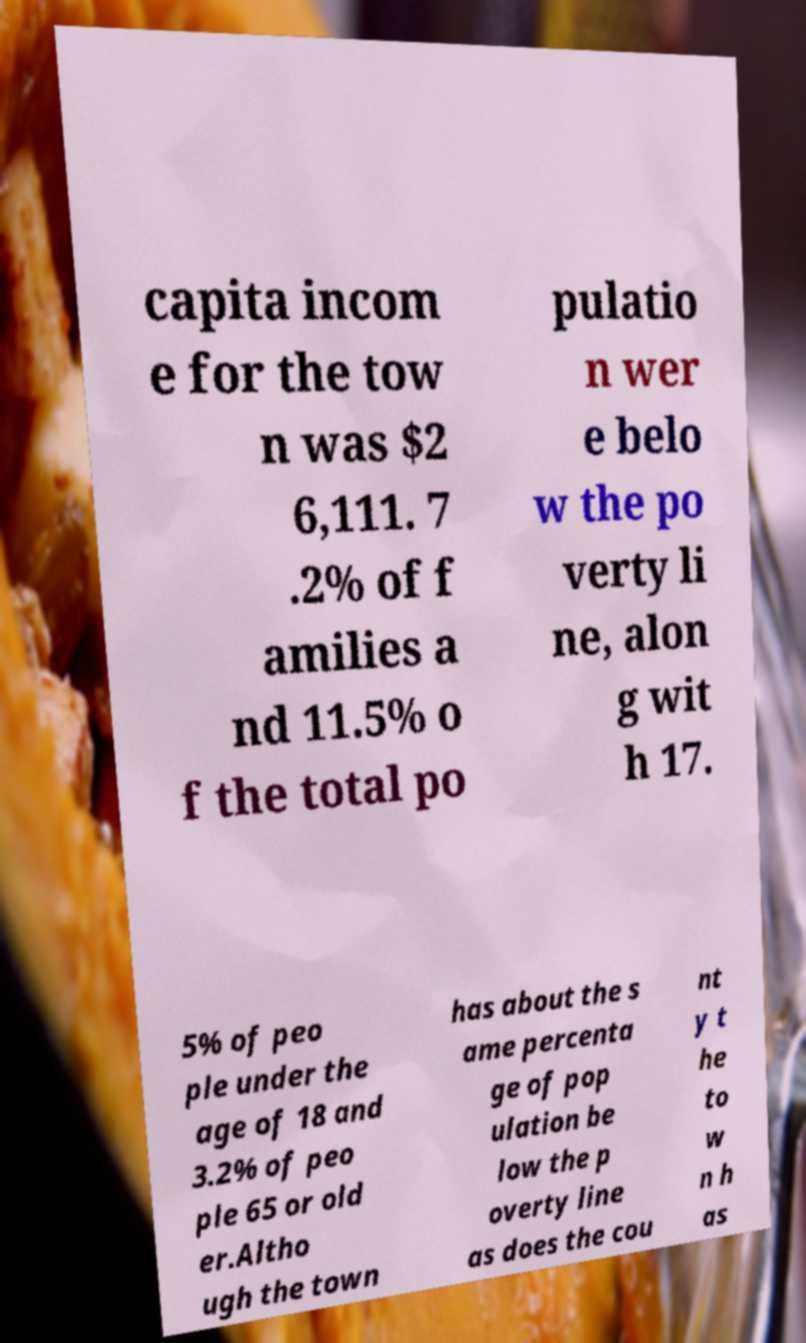There's text embedded in this image that I need extracted. Can you transcribe it verbatim? capita incom e for the tow n was $2 6,111. 7 .2% of f amilies a nd 11.5% o f the total po pulatio n wer e belo w the po verty li ne, alon g wit h 17. 5% of peo ple under the age of 18 and 3.2% of peo ple 65 or old er.Altho ugh the town has about the s ame percenta ge of pop ulation be low the p overty line as does the cou nt y t he to w n h as 